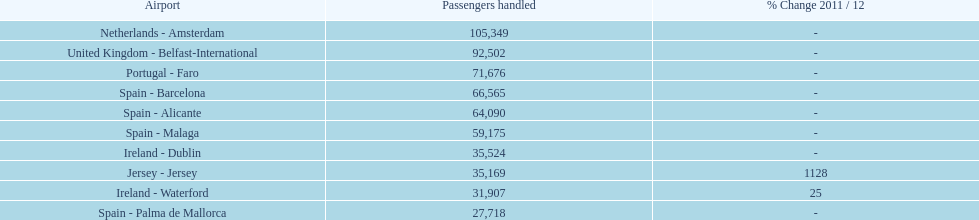Examining the top 10 most active routes to and from london southend airport, what is the average quantity of passengers managed? 58,967.5. Could you help me parse every detail presented in this table? {'header': ['Airport', 'Passengers handled', '% Change 2011 / 12'], 'rows': [['Netherlands - Amsterdam', '105,349', '-'], ['United Kingdom - Belfast-International', '92,502', '-'], ['Portugal - Faro', '71,676', '-'], ['Spain - Barcelona', '66,565', '-'], ['Spain - Alicante', '64,090', '-'], ['Spain - Malaga', '59,175', '-'], ['Ireland - Dublin', '35,524', '-'], ['Jersey - Jersey', '35,169', '1128'], ['Ireland - Waterford', '31,907', '25'], ['Spain - Palma de Mallorca', '27,718', '-']]} 